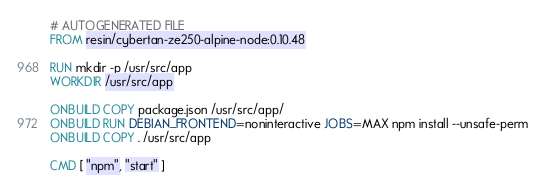<code> <loc_0><loc_0><loc_500><loc_500><_Dockerfile_># AUTOGENERATED FILE
FROM resin/cybertan-ze250-alpine-node:0.10.48

RUN mkdir -p /usr/src/app
WORKDIR /usr/src/app

ONBUILD COPY package.json /usr/src/app/
ONBUILD RUN DEBIAN_FRONTEND=noninteractive JOBS=MAX npm install --unsafe-perm
ONBUILD COPY . /usr/src/app

CMD [ "npm", "start" ]
</code> 